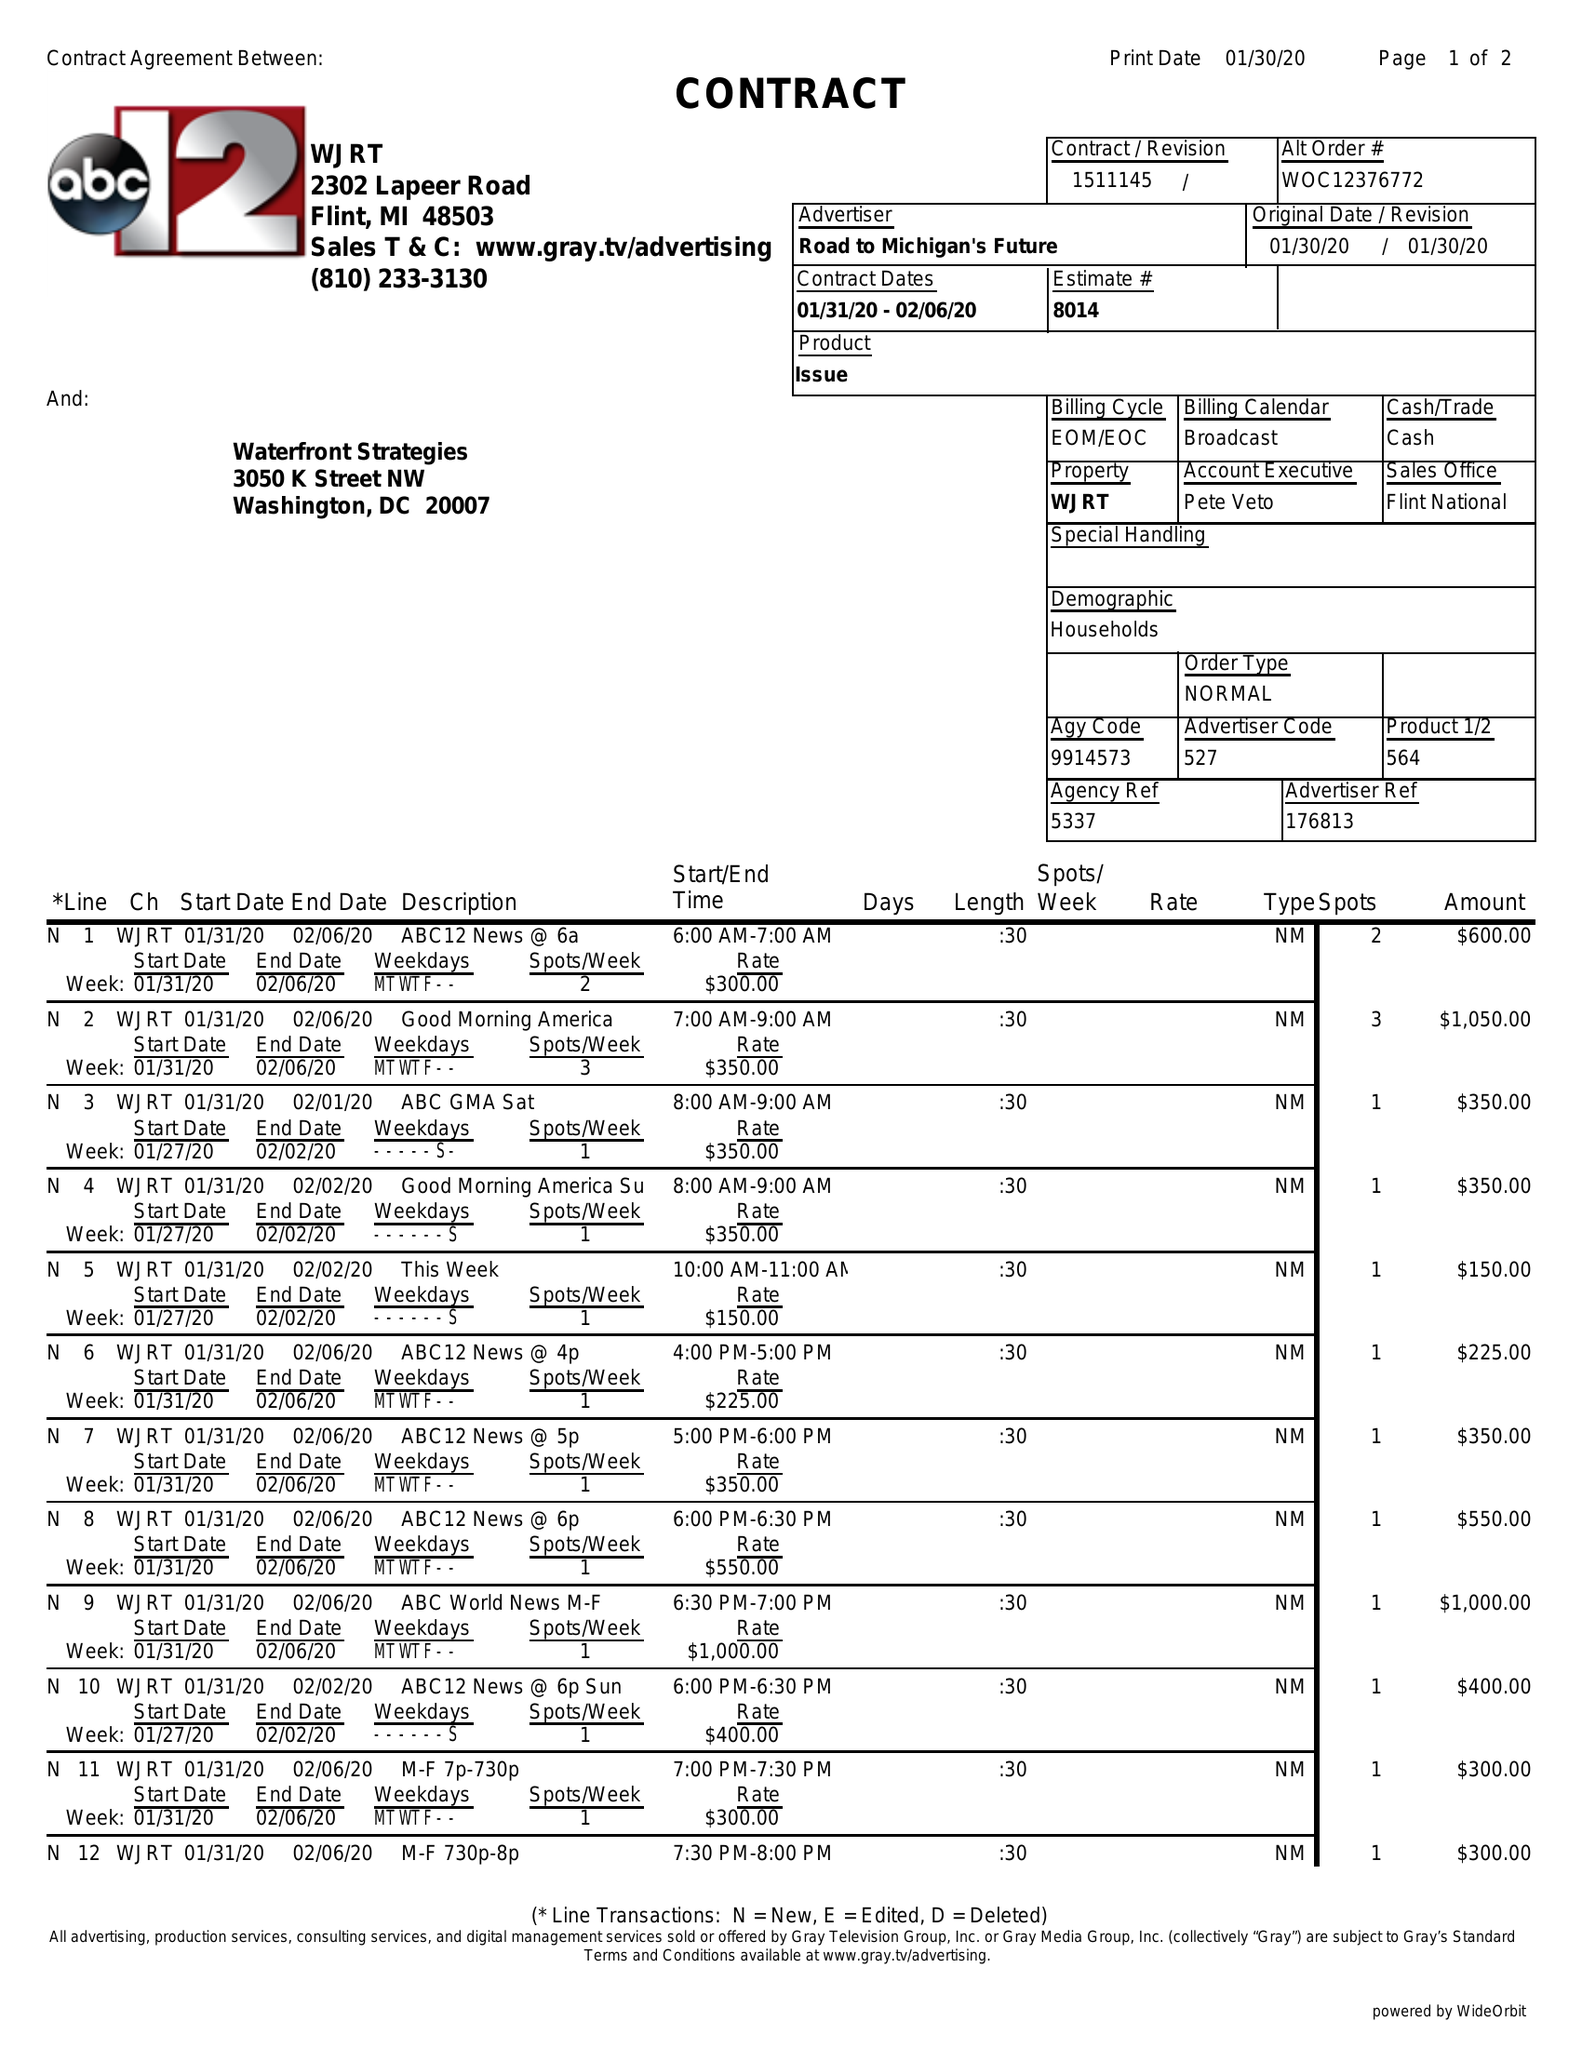What is the value for the contract_num?
Answer the question using a single word or phrase. 1511145 